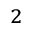<formula> <loc_0><loc_0><loc_500><loc_500>_ { 2 }</formula> 